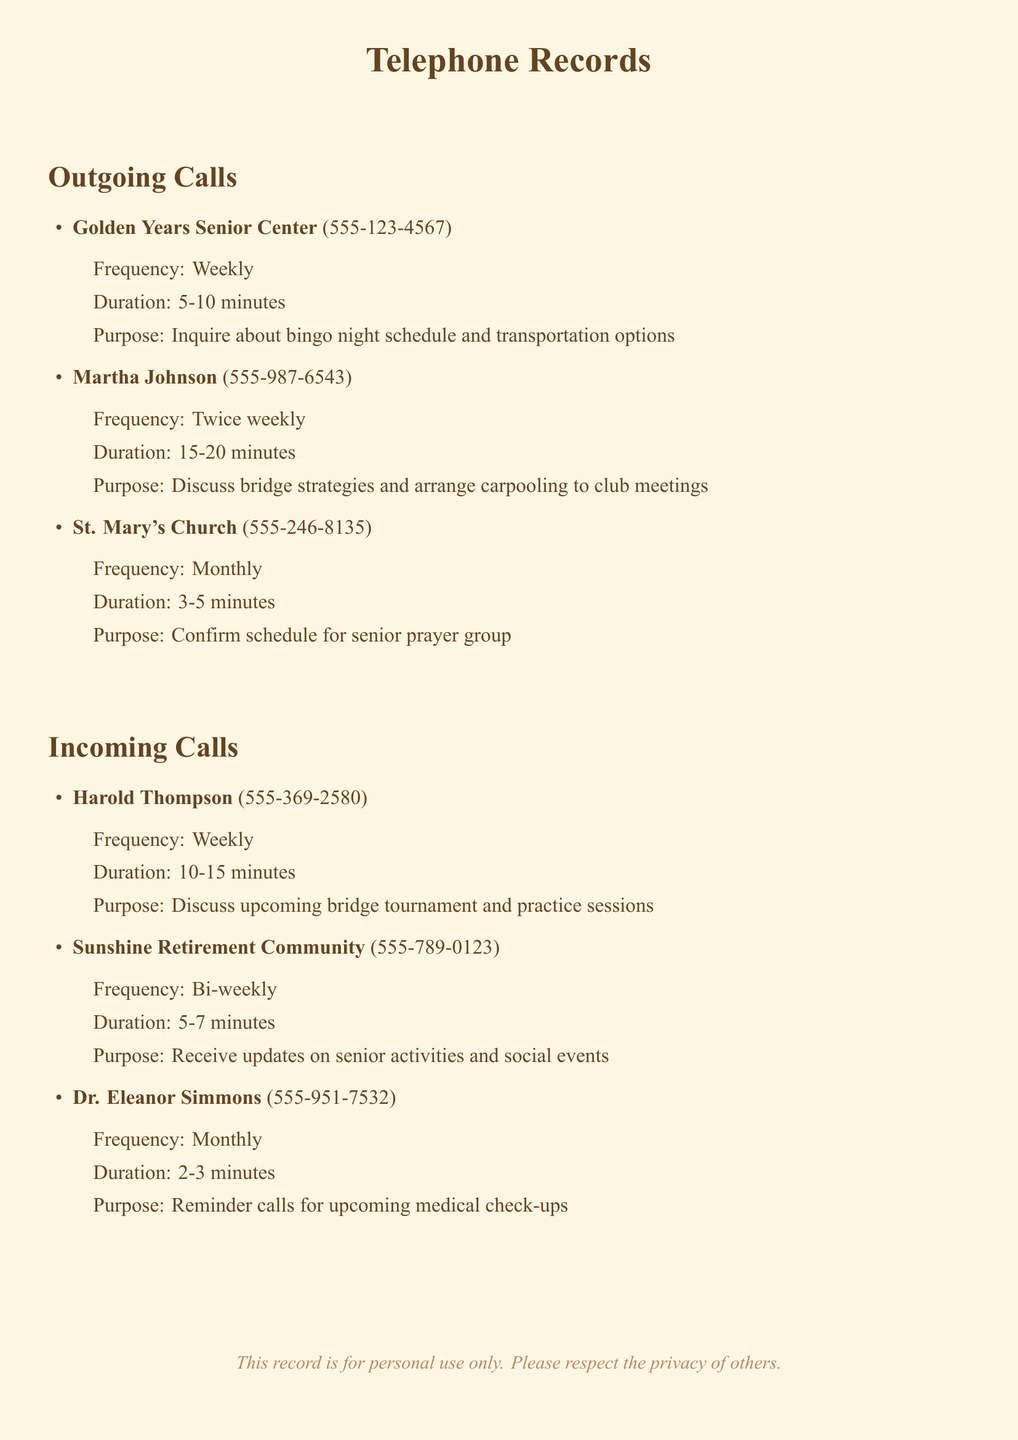What is the telephone number for Golden Years Senior Center? The telephone number for Golden Years Senior Center is listed in the outgoing calls section.
Answer: 555-123-4567 How often does Martha Johnson call? The frequency of calls from Martha Johnson is provided in the details of outgoing calls.
Answer: Twice weekly What is the duration of calls with Harold Thompson? The duration of calls with Harold Thompson is specified in the incoming calls section.
Answer: 10-15 minutes What is the purpose of the calls to St. Mary's Church? The purpose of the calls to St. Mary's Church is mentioned in the outgoing calls section.
Answer: Confirm schedule for senior prayer group How frequently does Sunshine Retirement Community call? The frequency of calls from Sunshine Retirement Community is provided in the incoming calls section.
Answer: Bi-weekly What is the longest duration for any incoming call? To find the longest duration for incoming calls, we compare the durations listed in the document.
Answer: 10-15 minutes How many calls were made to the Golden Years Senior Center in a month? The frequency of calls to the Golden Years Senior Center indicates how many calls are made in a month.
Answer: 4 Which member is discussed in relation to carpooling? The individual related to carpooling is specified in the outgoing calls section.
Answer: Martha Johnson What type of events does Harold Thompson discuss? The events discussed by Harold Thompson are mentioned in the incoming calls section.
Answer: Bridge tournament 